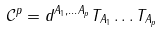<formula> <loc_0><loc_0><loc_500><loc_500>\mathcal { C } ^ { p } = d ^ { A _ { 1 } , \dots A _ { p } } T _ { A _ { 1 } } \dots T _ { A _ { p } }</formula> 